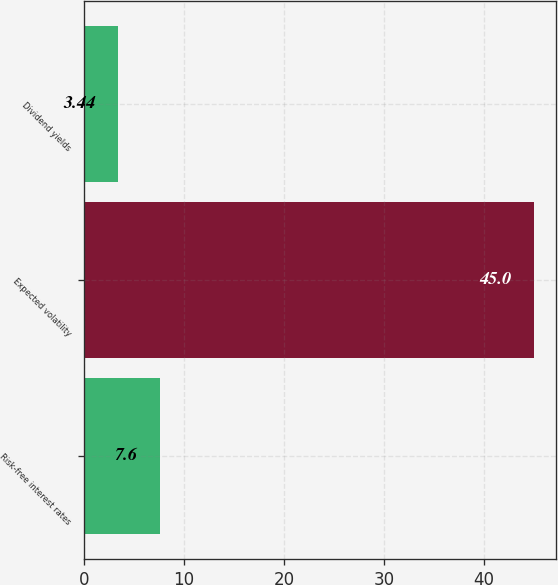<chart> <loc_0><loc_0><loc_500><loc_500><bar_chart><fcel>Risk-free interest rates<fcel>Expected volatility<fcel>Dividend yields<nl><fcel>7.6<fcel>45<fcel>3.44<nl></chart> 